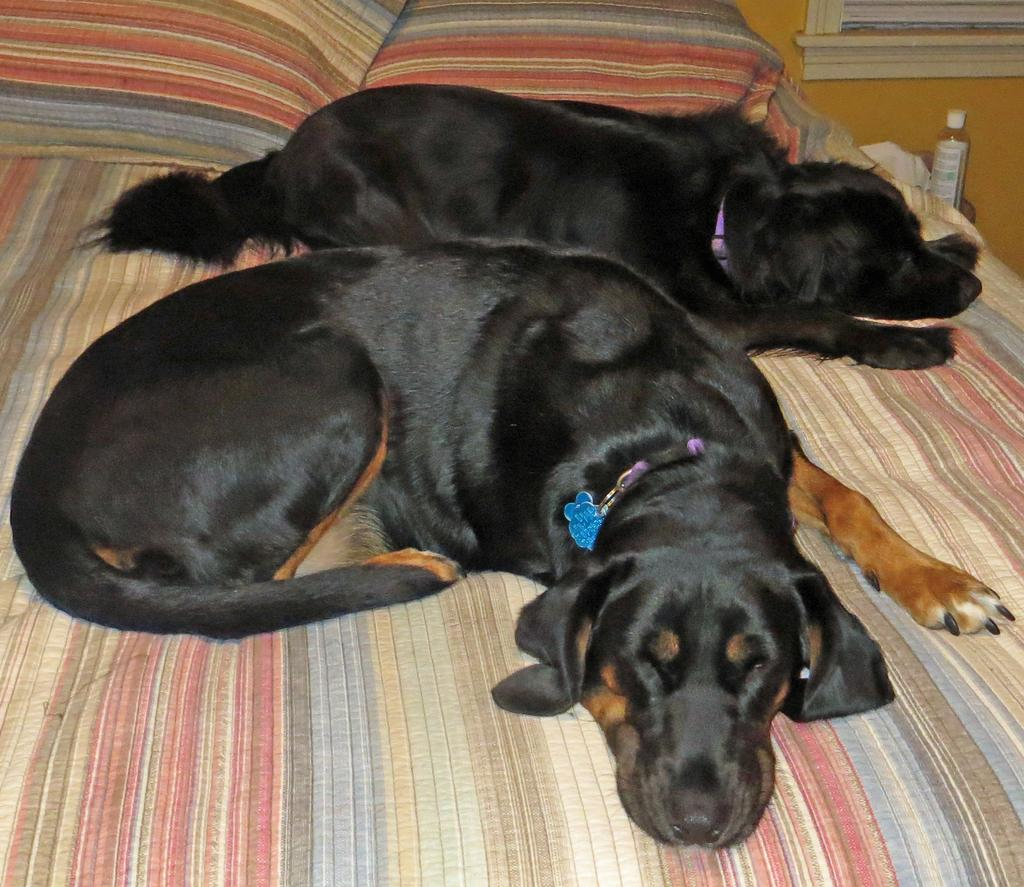What animals can be seen in the image? There are two dogs sleeping on the bed in the image. What objects are present on the bed? There are two pillows on the bed in the image. What is the bottle in the image used for? The purpose of the bottle in the image is not specified, but it could be for water or other beverages. What color is the cloth visible in the image? The cloth in the image is white. What can be seen in the background of the image? There is a wall visible in the background of the image. What type of zoo animals can be seen in the image? There are no zoo animals present in the image; it features two dogs sleeping on a bed. What industry is represented by the objects in the image? The image does not represent any specific industry; it is a domestic scene with dogs, pillows, and a bottle. 